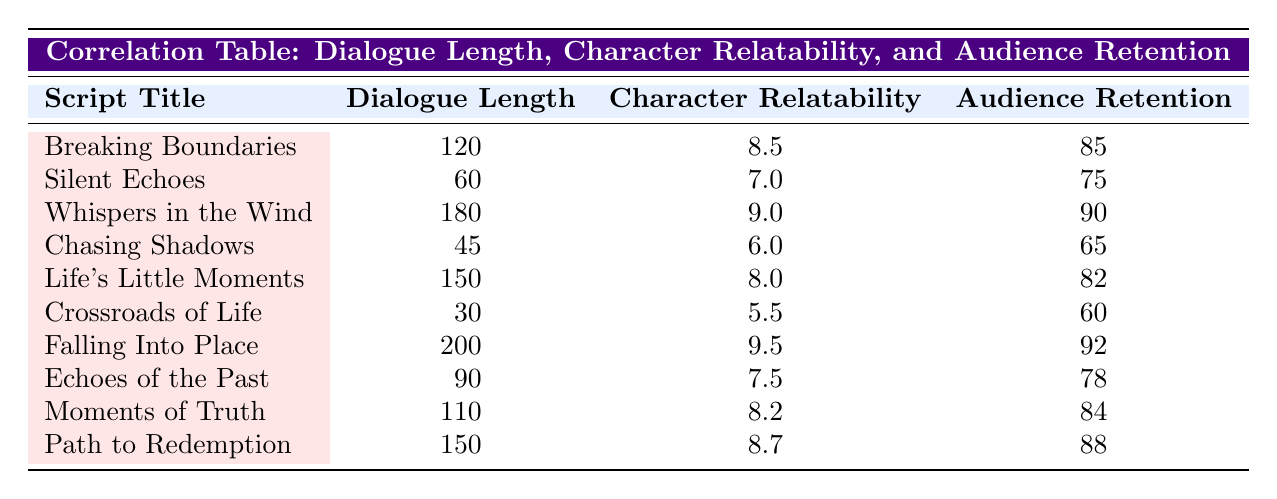What is the character relatability score for "Falling Into Place"? The table lists "Falling Into Place" in the first column, with its corresponding character relatability score located in the third column, which is 9.5.
Answer: 9.5 What is the dialogue length of "Chasing Shadows"? Looking at the row for "Chasing Shadows," the dialogue length is found in the second column, which reads 45.
Answer: 45 Which script has the highest audience retention rate? By examining the audience retention rates across all rows, "Falling Into Place" has the highest value in the fourth column at 92.
Answer: Falling Into Place What is the average dialogue length of all the scripts? To find the average, we sum all the dialogue lengths (120 + 60 + 180 + 45 + 150 + 30 + 200 + 90 + 110 + 150) = 1,125. Then we divide by the number of scripts (10), resulting in an average dialogue length of 112.5.
Answer: 112.5 Is "Whispers in the Wind" more relatable than "Silent Echoes"? Comparing the character relatability scores for both scripts, "Whispers in the Wind" has a score of 9.0 while "Silent Echoes" has 7.0, making it clear that "Whispers in the Wind" is indeed more relatable.
Answer: Yes What is the difference in audience retention rates between "Path to Redemption" and "Chasing Shadows"? The audience retention rate for "Path to Redemption" is 88, while for "Chasing Shadows" it is 65. The difference is calculated as 88 - 65 = 23.
Answer: 23 Are there any scripts with a dialogue length of 150? By scanning the dialogue lengths in the table, it is evident that there are two scripts, "Life's Little Moments" and "Path to Redemption," both of which have a dialogue length of 150.
Answer: Yes Which script has the lowest character relatability score? Identifying the character relatability scores, "Crossroads of Life" has the lowest score at 5.5, as seen in its respective row.
Answer: Crossroads of Life What is the median audience retention rate among the scripts? To find the median, we first list the audience retention rates in ascending order: 60, 65, 75, 78, 82, 84, 85, 88, 90, 92. With 10 data points, the median is found between the 5th (82) and 6th (84) values, so (82 + 84) / 2 = 83.
Answer: 83 